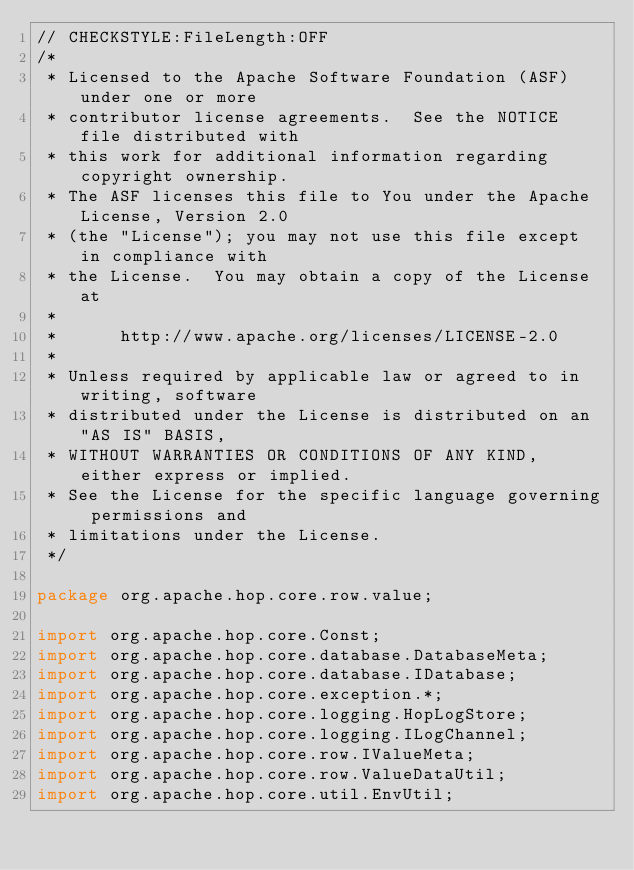Convert code to text. <code><loc_0><loc_0><loc_500><loc_500><_Java_>// CHECKSTYLE:FileLength:OFF
/*
 * Licensed to the Apache Software Foundation (ASF) under one or more
 * contributor license agreements.  See the NOTICE file distributed with
 * this work for additional information regarding copyright ownership.
 * The ASF licenses this file to You under the Apache License, Version 2.0
 * (the "License"); you may not use this file except in compliance with
 * the License.  You may obtain a copy of the License at
 *
 *      http://www.apache.org/licenses/LICENSE-2.0
 *
 * Unless required by applicable law or agreed to in writing, software
 * distributed under the License is distributed on an "AS IS" BASIS,
 * WITHOUT WARRANTIES OR CONDITIONS OF ANY KIND, either express or implied.
 * See the License for the specific language governing permissions and
 * limitations under the License.
 */

package org.apache.hop.core.row.value;

import org.apache.hop.core.Const;
import org.apache.hop.core.database.DatabaseMeta;
import org.apache.hop.core.database.IDatabase;
import org.apache.hop.core.exception.*;
import org.apache.hop.core.logging.HopLogStore;
import org.apache.hop.core.logging.ILogChannel;
import org.apache.hop.core.row.IValueMeta;
import org.apache.hop.core.row.ValueDataUtil;
import org.apache.hop.core.util.EnvUtil;</code> 